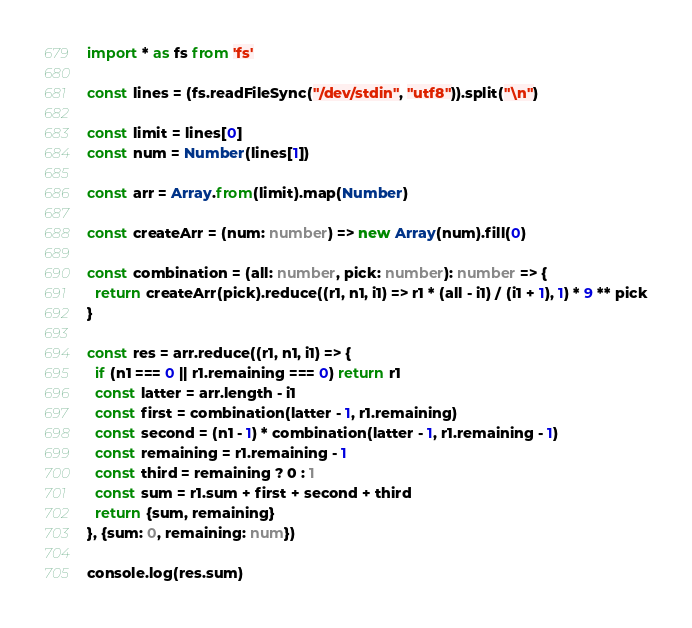Convert code to text. <code><loc_0><loc_0><loc_500><loc_500><_TypeScript_>import * as fs from 'fs'

const lines = (fs.readFileSync("/dev/stdin", "utf8")).split("\n")

const limit = lines[0]
const num = Number(lines[1])

const arr = Array.from(limit).map(Number)

const createArr = (num: number) => new Array(num).fill(0)

const combination = (all: number, pick: number): number => {
  return createArr(pick).reduce((r1, n1, i1) => r1 * (all - i1) / (i1 + 1), 1) * 9 ** pick
}

const res = arr.reduce((r1, n1, i1) => {
  if (n1 === 0 || r1.remaining === 0) return r1
  const latter = arr.length - i1
  const first = combination(latter - 1, r1.remaining)
  const second = (n1 - 1) * combination(latter - 1, r1.remaining - 1)
  const remaining = r1.remaining - 1
  const third = remaining ? 0 : 1
  const sum = r1.sum + first + second + third
  return {sum, remaining}
}, {sum: 0, remaining: num})

console.log(res.sum)
</code> 